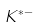Convert formula to latex. <formula><loc_0><loc_0><loc_500><loc_500>K ^ { * - }</formula> 